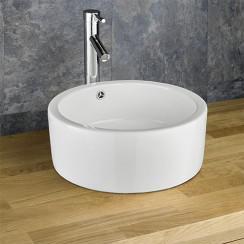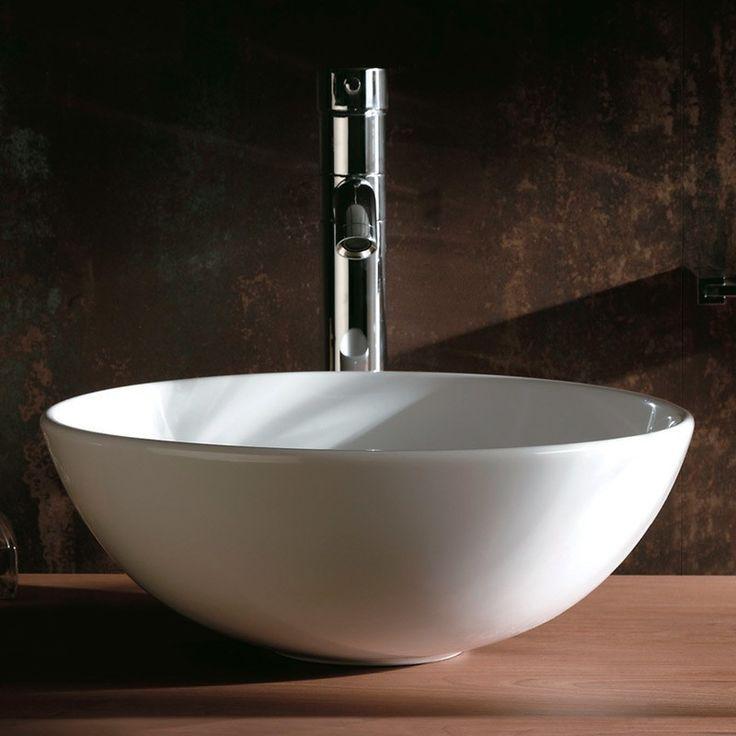The first image is the image on the left, the second image is the image on the right. Analyze the images presented: Is the assertion "All sink faucets are a vertical chrome pipe with a horizontal piece extending over the sink bowl." valid? Answer yes or no. Yes. The first image is the image on the left, the second image is the image on the right. Considering the images on both sides, is "At least one of the sinks depicted has lever handles flanking the faucet." valid? Answer yes or no. No. 